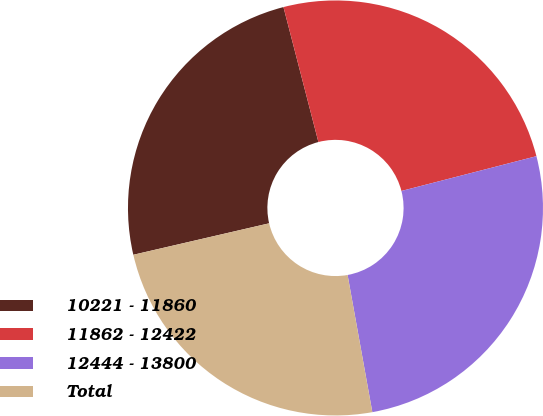Convert chart to OTSL. <chart><loc_0><loc_0><loc_500><loc_500><pie_chart><fcel>10221 - 11860<fcel>11862 - 12422<fcel>12444 - 13800<fcel>Total<nl><fcel>24.59%<fcel>25.02%<fcel>26.17%<fcel>24.22%<nl></chart> 